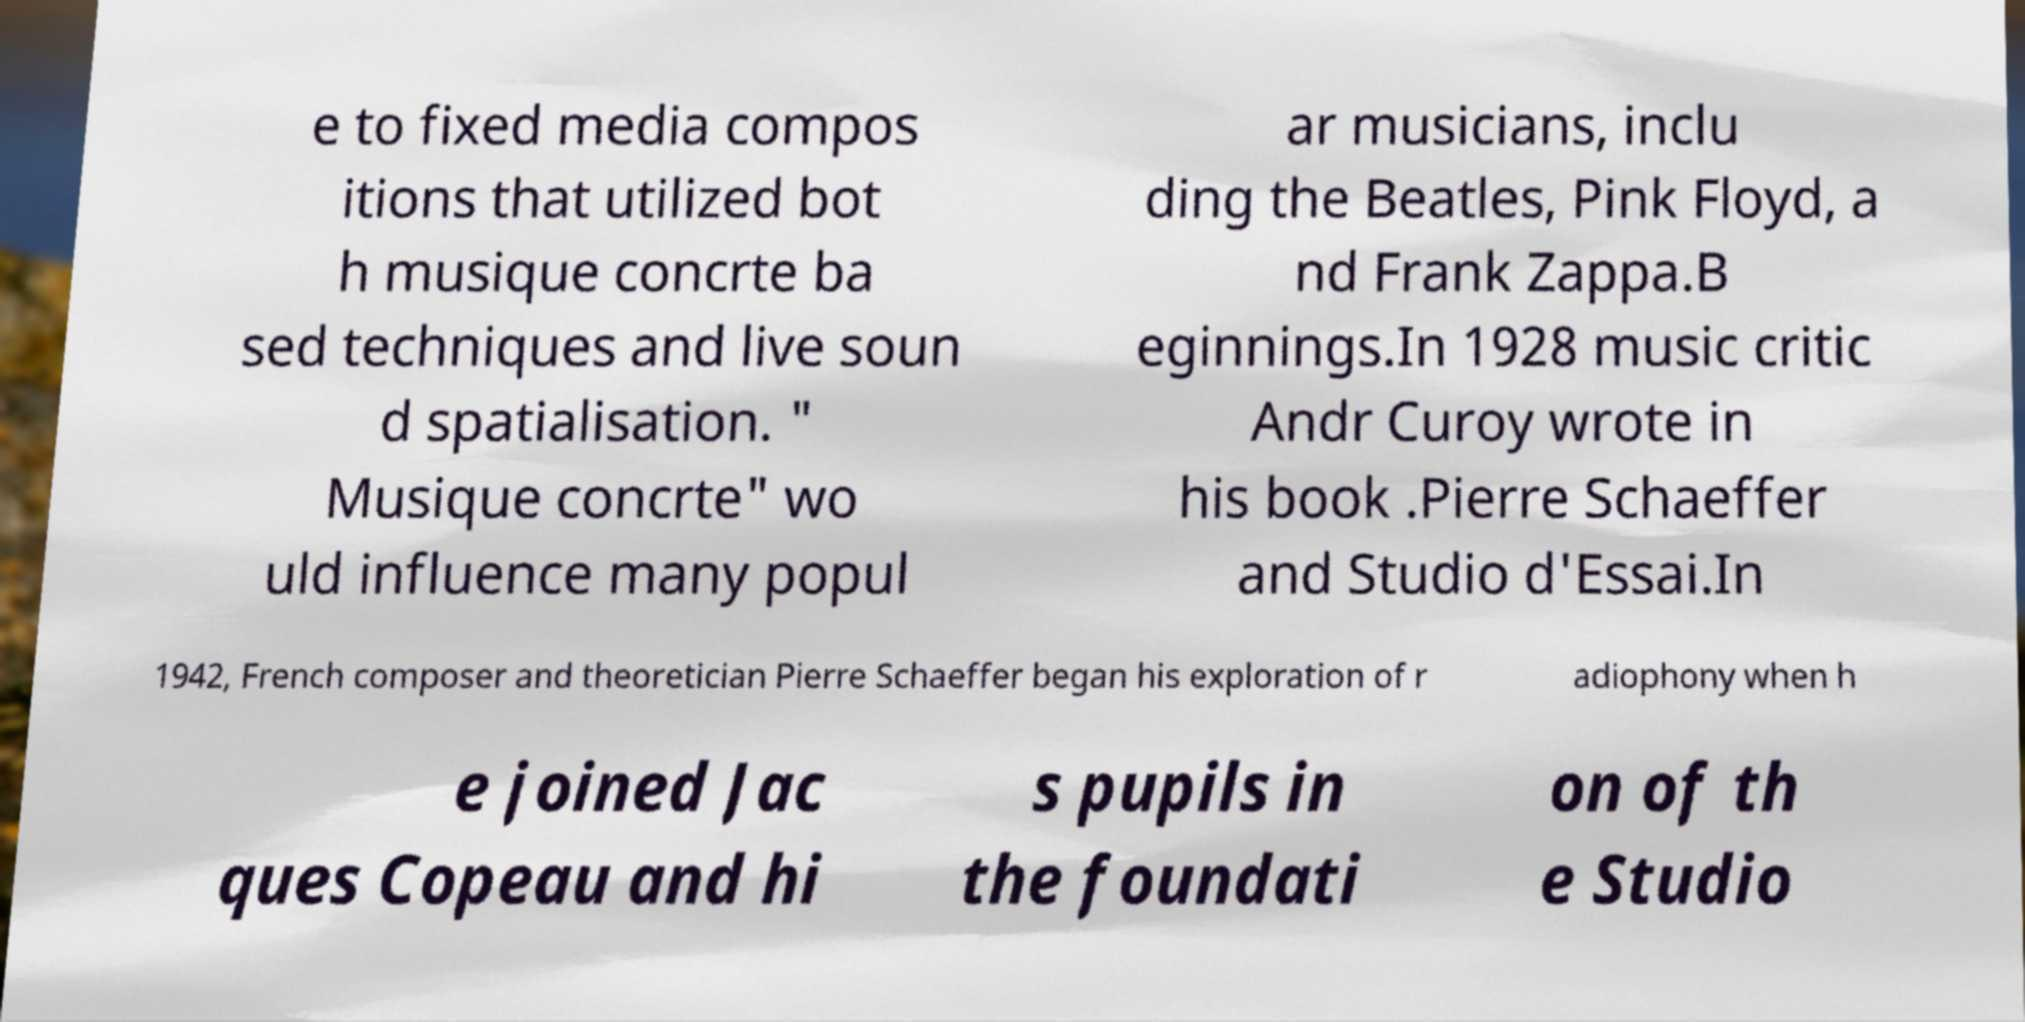There's text embedded in this image that I need extracted. Can you transcribe it verbatim? e to fixed media compos itions that utilized bot h musique concrte ba sed techniques and live soun d spatialisation. " Musique concrte" wo uld influence many popul ar musicians, inclu ding the Beatles, Pink Floyd, a nd Frank Zappa.B eginnings.In 1928 music critic Andr Curoy wrote in his book .Pierre Schaeffer and Studio d'Essai.In 1942, French composer and theoretician Pierre Schaeffer began his exploration of r adiophony when h e joined Jac ques Copeau and hi s pupils in the foundati on of th e Studio 